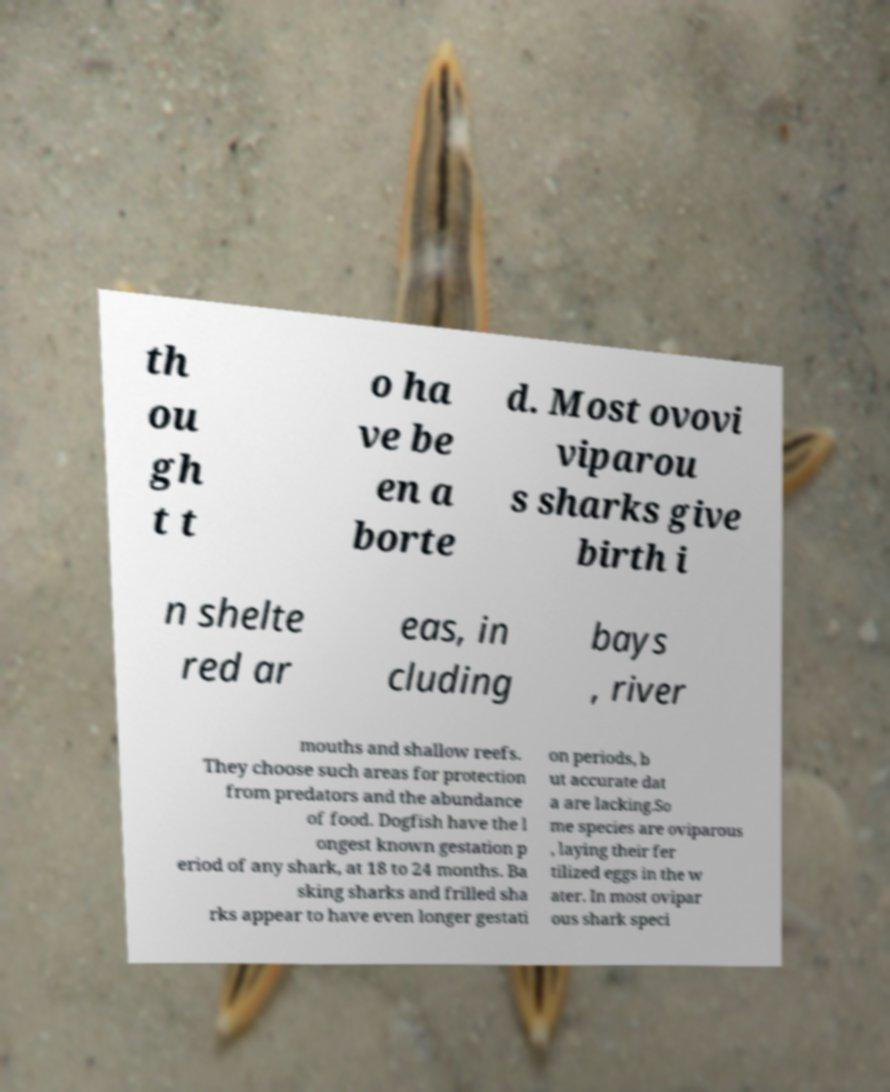Could you assist in decoding the text presented in this image and type it out clearly? th ou gh t t o ha ve be en a borte d. Most ovovi viparou s sharks give birth i n shelte red ar eas, in cluding bays , river mouths and shallow reefs. They choose such areas for protection from predators and the abundance of food. Dogfish have the l ongest known gestation p eriod of any shark, at 18 to 24 months. Ba sking sharks and frilled sha rks appear to have even longer gestati on periods, b ut accurate dat a are lacking.So me species are oviparous , laying their fer tilized eggs in the w ater. In most ovipar ous shark speci 